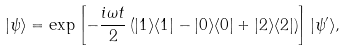Convert formula to latex. <formula><loc_0><loc_0><loc_500><loc_500>| \psi \rangle = \exp \left [ - \frac { i \omega t } { 2 } \left ( | 1 \rangle \langle 1 | - | 0 \rangle \langle 0 | + | 2 \rangle \langle 2 | \right ) \right ] | \psi ^ { \prime } \rangle ,</formula> 